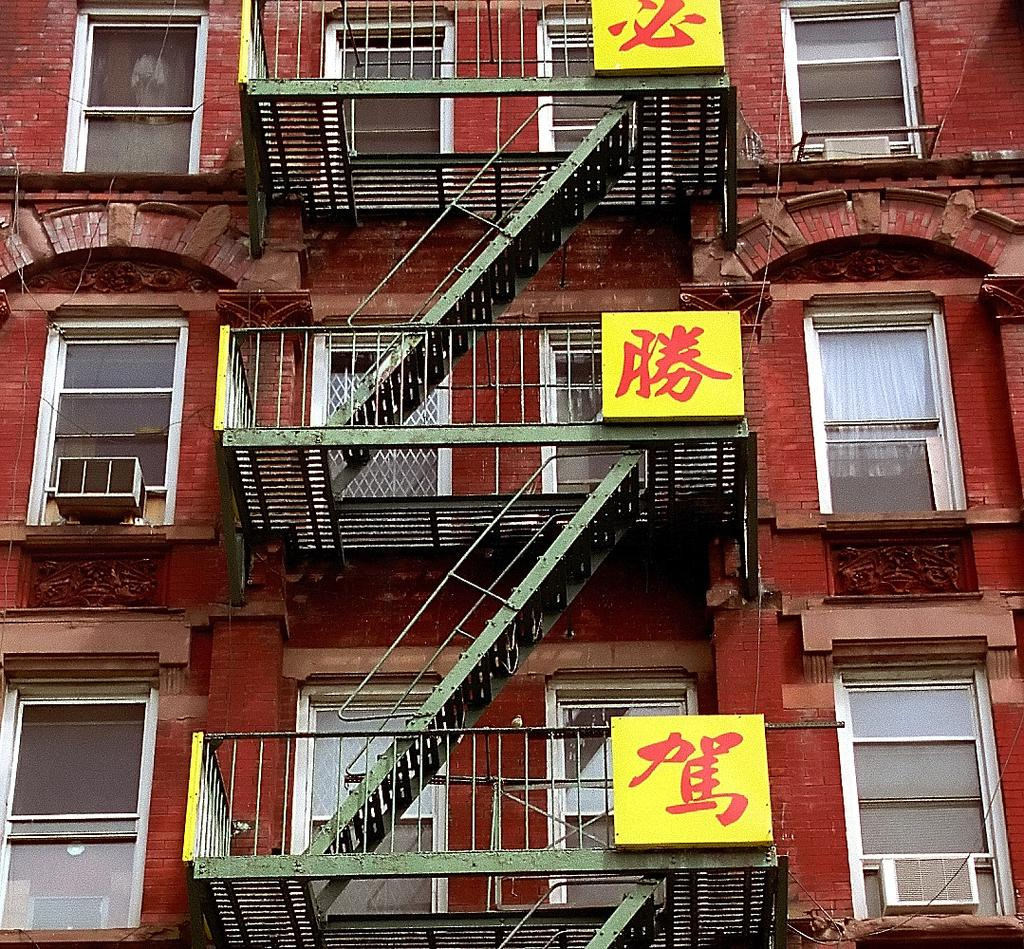What type of structure is present in the image? There is a building in the image. What are some notable features of the building? The building has many windows and doors. Can you describe the stairs in the image? The stairs are in front of the door and are constructed and attached to the balcony of each floor. What type of powder is being used to clean the windows in the image? There is no indication of any cleaning activity or powder in the image. 